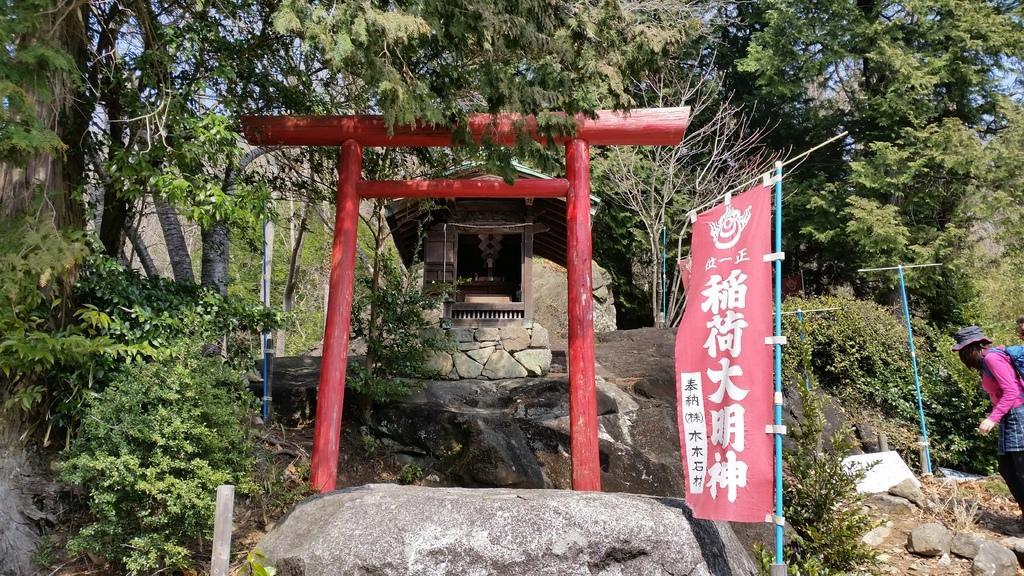How would you summarize this image in a sentence or two? This image consists of a small hut. At the bottom, there are rocks. In the front, we can see a banner and a wooden arch. In the background, there are many trees. On the right, there is a person wearing a backpack. 